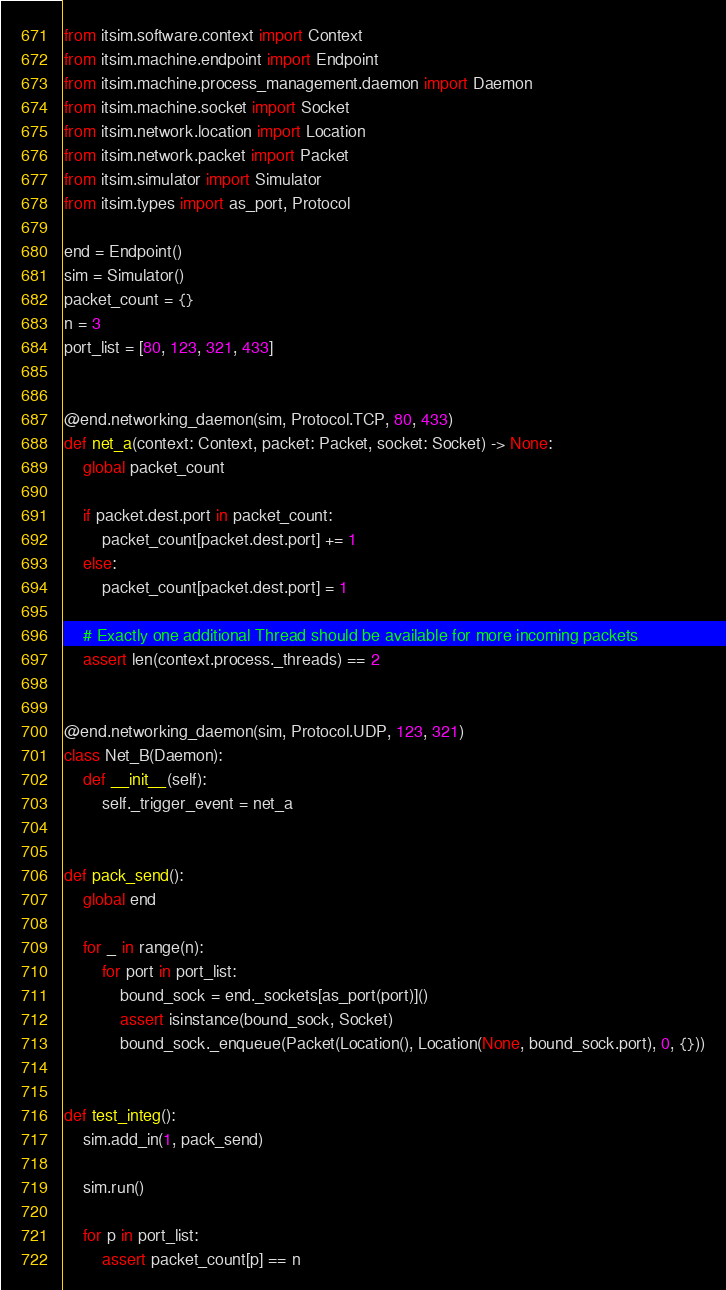<code> <loc_0><loc_0><loc_500><loc_500><_Python_>from itsim.software.context import Context
from itsim.machine.endpoint import Endpoint
from itsim.machine.process_management.daemon import Daemon
from itsim.machine.socket import Socket
from itsim.network.location import Location
from itsim.network.packet import Packet
from itsim.simulator import Simulator
from itsim.types import as_port, Protocol

end = Endpoint()
sim = Simulator()
packet_count = {}
n = 3
port_list = [80, 123, 321, 433]


@end.networking_daemon(sim, Protocol.TCP, 80, 433)
def net_a(context: Context, packet: Packet, socket: Socket) -> None:
    global packet_count

    if packet.dest.port in packet_count:
        packet_count[packet.dest.port] += 1
    else:
        packet_count[packet.dest.port] = 1

    # Exactly one additional Thread should be available for more incoming packets
    assert len(context.process._threads) == 2


@end.networking_daemon(sim, Protocol.UDP, 123, 321)
class Net_B(Daemon):
    def __init__(self):
        self._trigger_event = net_a


def pack_send():
    global end

    for _ in range(n):
        for port in port_list:
            bound_sock = end._sockets[as_port(port)]()
            assert isinstance(bound_sock, Socket)
            bound_sock._enqueue(Packet(Location(), Location(None, bound_sock.port), 0, {}))


def test_integ():
    sim.add_in(1, pack_send)

    sim.run()

    for p in port_list:
        assert packet_count[p] == n
</code> 